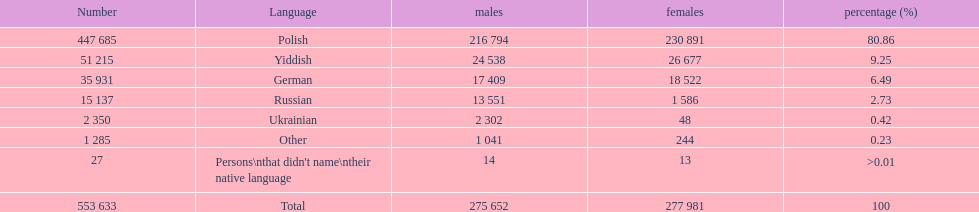Could you parse the entire table as a dict? {'header': ['Number', 'Language', 'males', 'females', 'percentage (%)'], 'rows': [['447 685', 'Polish', '216 794', '230 891', '80.86'], ['51 215', 'Yiddish', '24 538', '26 677', '9.25'], ['35 931', 'German', '17 409', '18 522', '6.49'], ['15 137', 'Russian', '13 551', '1 586', '2.73'], ['2 350', 'Ukrainian', '2 302', '48', '0.42'], ['1 285', 'Other', '1 041', '244', '0.23'], ['27', "Persons\\nthat didn't name\\ntheir native language", '14', '13', '>0.01'], ['553 633', 'Total', '275 652', '277 981', '100']]} Which language did only .42% of people in the imperial census of 1897 speak in the p&#322;ock governorate? Ukrainian. 